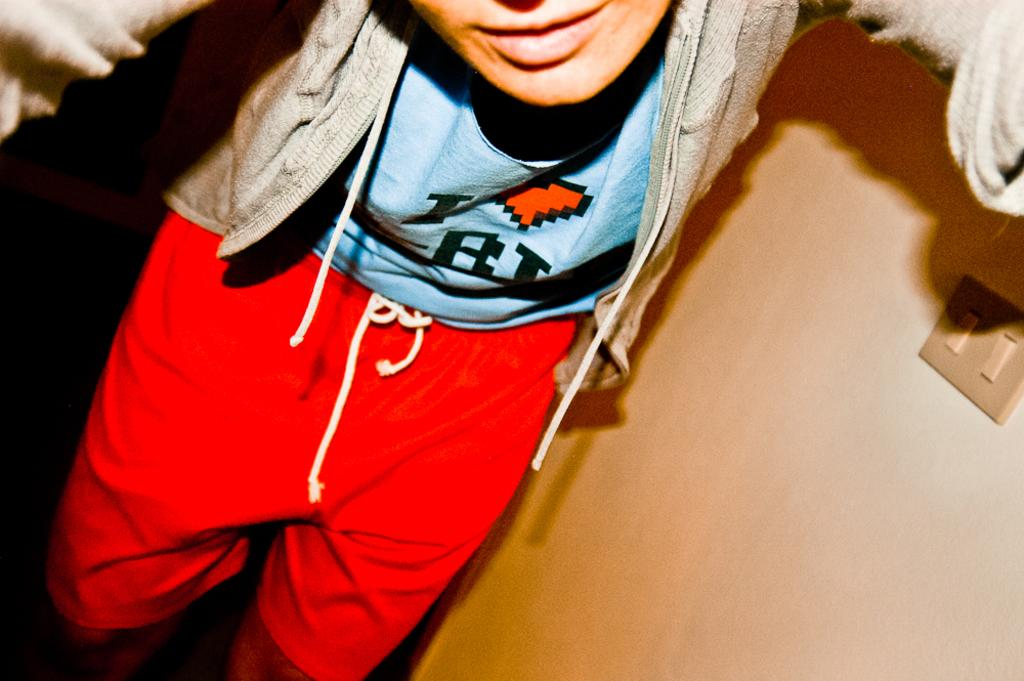What is the main subject of the image? There is a person in the image. What is the person wearing on their lower body? The person is wearing a red-colored short. What is the person wearing on their upper body? The person is wearing a blue-colored top and an ash-colored sweater. What can be seen on the right side of the image? There are electric switches on the right side of the image. Can you tell me how many times the person smiles in the image? The provided facts do not mention the person's facial expression, so we cannot determine if they are smiling or not. What type of line is present in the image? There is no line mentioned in the provided facts, so we cannot answer this question. 